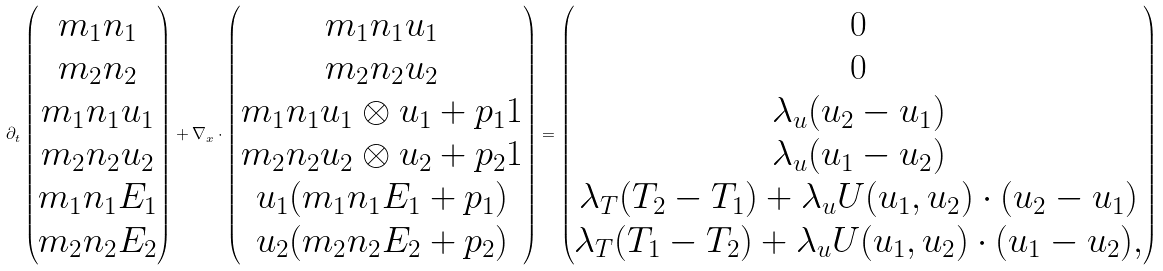Convert formula to latex. <formula><loc_0><loc_0><loc_500><loc_500>\partial _ { t } \begin{pmatrix} m _ { 1 } n _ { 1 } \\ m _ { 2 } n _ { 2 } \\ m _ { 1 } n _ { 1 } u _ { 1 } \\ m _ { 2 } n _ { 2 } u _ { 2 } \\ m _ { 1 } n _ { 1 } E _ { 1 } \\ m _ { 2 } n _ { 2 } E _ { 2 } \end{pmatrix} + \nabla _ { x } \cdot \begin{pmatrix} m _ { 1 } n _ { 1 } u _ { 1 } \\ m _ { 2 } n _ { 2 } u _ { 2 } \\ m _ { 1 } n _ { 1 } u _ { 1 } \otimes u _ { 1 } + p _ { 1 } 1 \\ m _ { 2 } n _ { 2 } u _ { 2 } \otimes u _ { 2 } + p _ { 2 } 1 \\ u _ { 1 } ( m _ { 1 } n _ { 1 } E _ { 1 } + p _ { 1 } ) \\ u _ { 2 } ( m _ { 2 } n _ { 2 } E _ { 2 } + p _ { 2 } ) \end{pmatrix} = \begin{pmatrix} 0 \\ 0 \\ \lambda _ { u } ( u _ { 2 } - u _ { 1 } ) \\ \lambda _ { u } ( u _ { 1 } - u _ { 2 } ) \\ \lambda _ { T } ( T _ { 2 } - T _ { 1 } ) + \lambda _ { u } U ( u _ { 1 } , u _ { 2 } ) \cdot ( u _ { 2 } - u _ { 1 } ) \\ \lambda _ { T } ( T _ { 1 } - T _ { 2 } ) + \lambda _ { u } U ( u _ { 1 } , u _ { 2 } ) \cdot ( u _ { 1 } - u _ { 2 } ) , \end{pmatrix}</formula> 